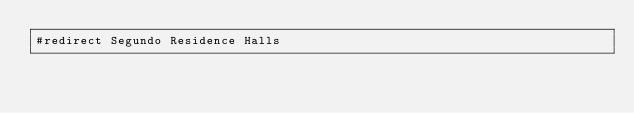<code> <loc_0><loc_0><loc_500><loc_500><_FORTRAN_>#redirect Segundo Residence Halls
</code> 